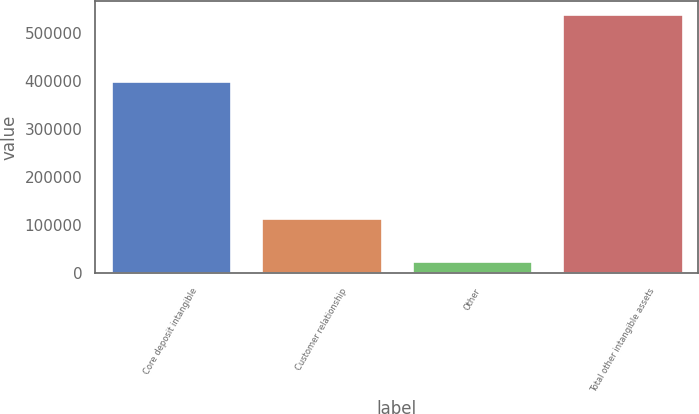<chart> <loc_0><loc_0><loc_500><loc_500><bar_chart><fcel>Core deposit intangible<fcel>Customer relationship<fcel>Other<fcel>Total other intangible assets<nl><fcel>400058<fcel>116094<fcel>25164<fcel>541316<nl></chart> 